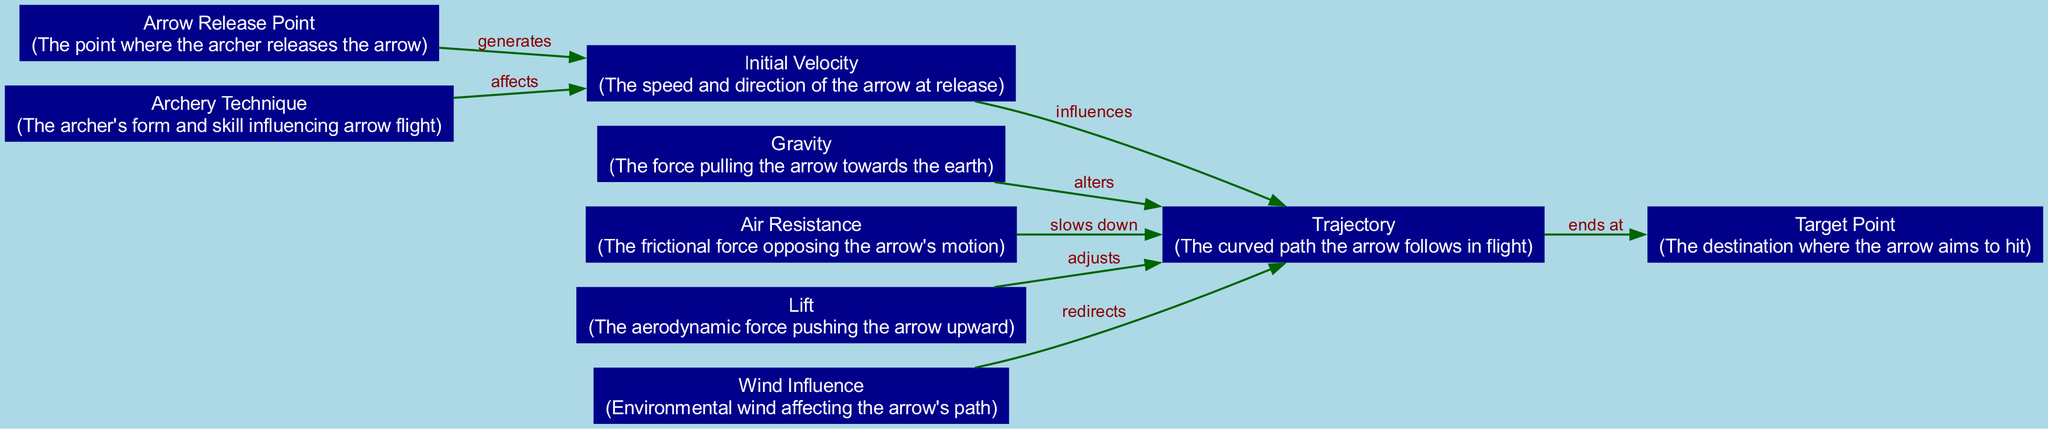What is the release point of the arrow? According to the diagram, the node labeled "Arrow Release Point" represents the starting point where the arrow is released by the archer.
Answer: Arrow Release Point How many forces are acting on the arrow during flight? The diagram identifies three main forces influencing the arrow's flight: Gravity, Air Resistance, and Lift. This can be counted from the nodes labeled under forces.
Answer: Three What does "Initial Velocity" influence? The diagram establishes a direct influence of the "Initial Velocity" on the "Trajectory" of the arrow, indicating that the speed and direction at release affect how the arrow travels.
Answer: Trajectory Which force acts to slow down the arrow? Based on the edges connecting nodes, "Air Resistance" is marked as the force that slows down the arrow, according to the edge labeled "slows down."
Answer: Air Resistance What is the outcome of the trajectory according to its path? The diagram indicates that the "Trajectory" ends at the "Target Point," which shows the intended destination of the arrow following its flight path.
Answer: Target Point What two factors influence the initial velocity of the arrow? The diagram specifies that "Archery Technique" affects the "Initial Velocity" and demonstrates how an archer's form influences the arrow's speed and direction at release.
Answer: Archery Technique and Initial Velocity How does wind influence the arrow? The diagram illustrates that environmental factors, such as "Wind Influence," can redirect the trajectory of the arrow, showing its impact on flight.
Answer: Redirects 